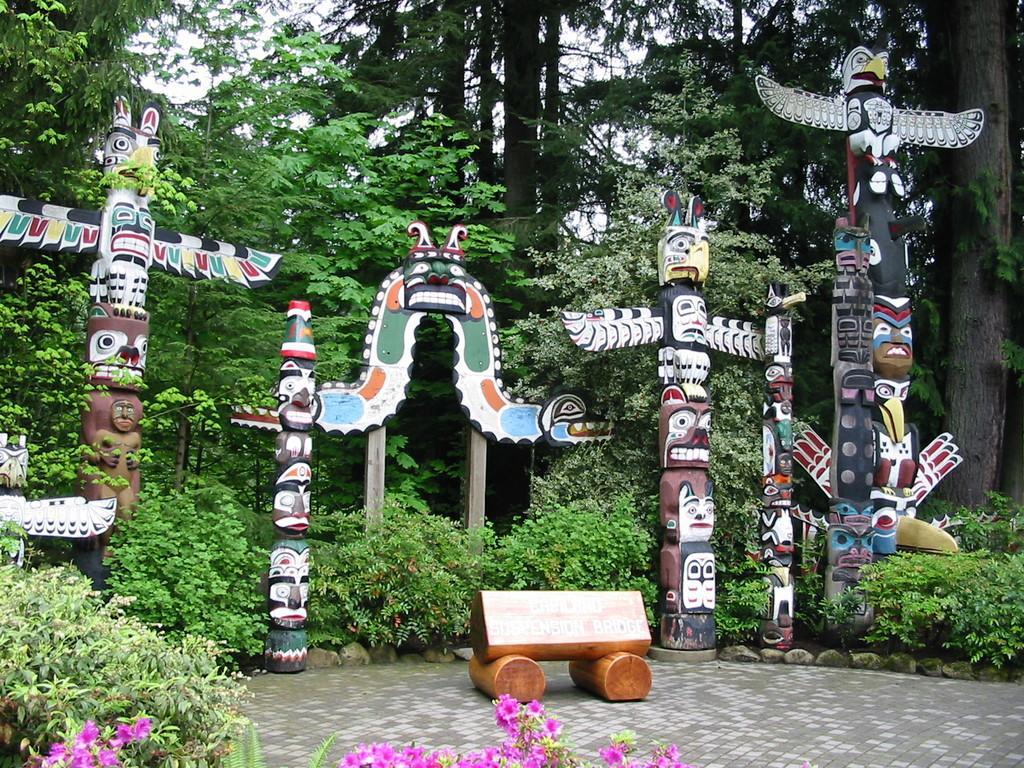Describe this image in one or two sentences. In this picture in can see trees few wooden carvings and painting on the wood and I see plants and few flowers and I can see couple of wooden barks and some text on it. 